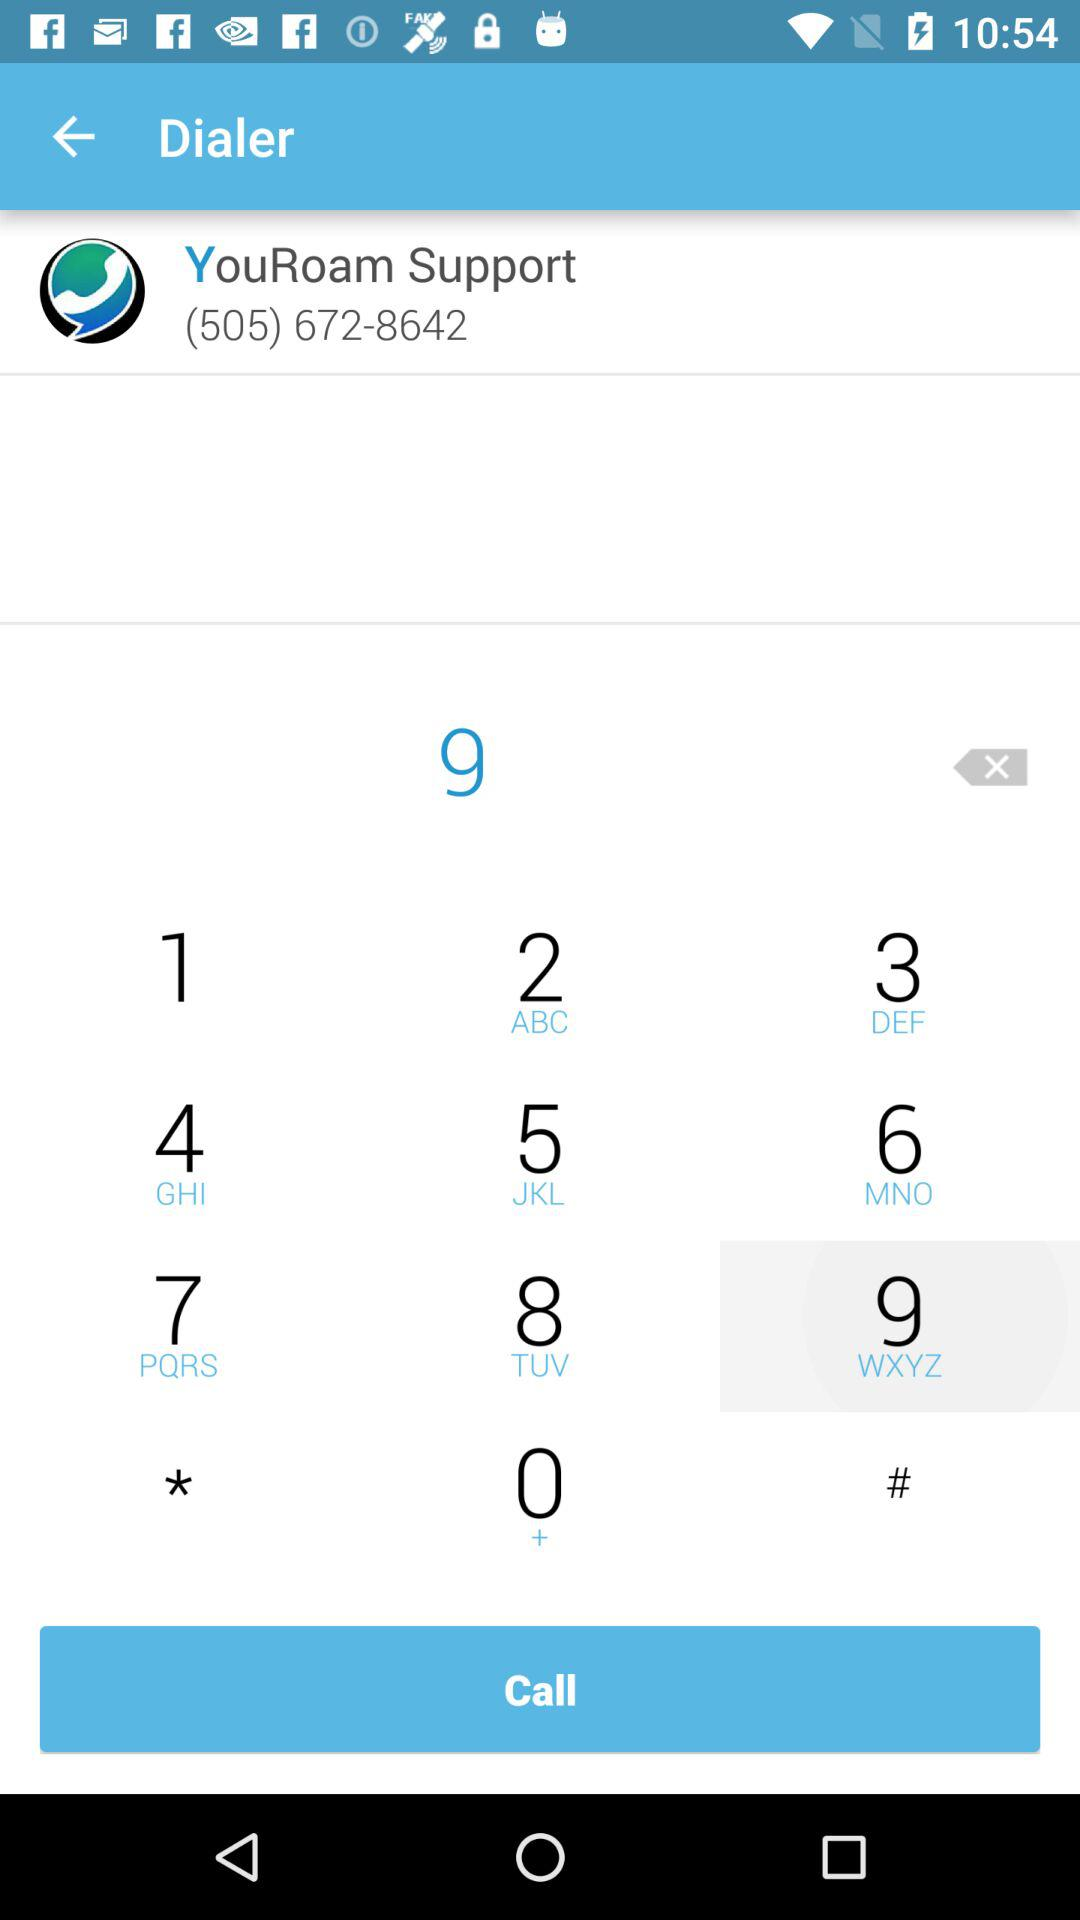What is the phone number of "YouRoam Support"? The phone number is (505) 672-8642. 